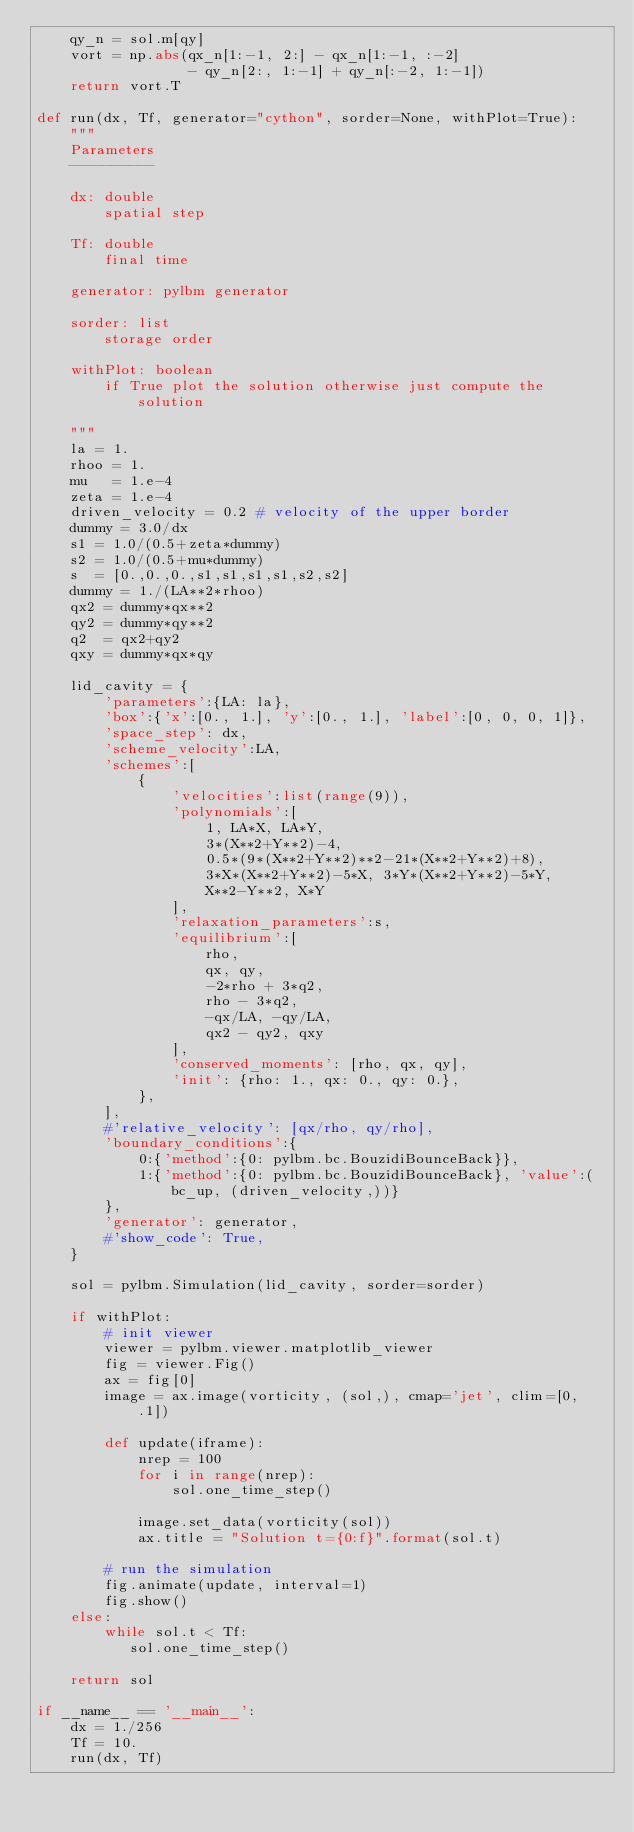<code> <loc_0><loc_0><loc_500><loc_500><_Python_>    qy_n = sol.m[qy]
    vort = np.abs(qx_n[1:-1, 2:] - qx_n[1:-1, :-2]
                  - qy_n[2:, 1:-1] + qy_n[:-2, 1:-1])
    return vort.T

def run(dx, Tf, generator="cython", sorder=None, withPlot=True):
    """
    Parameters
    ----------

    dx: double
        spatial step

    Tf: double
        final time

    generator: pylbm generator

    sorder: list
        storage order

    withPlot: boolean
        if True plot the solution otherwise just compute the solution

    """
    la = 1.
    rhoo = 1.
    mu   = 1.e-4
    zeta = 1.e-4
    driven_velocity = 0.2 # velocity of the upper border
    dummy = 3.0/dx
    s1 = 1.0/(0.5+zeta*dummy)
    s2 = 1.0/(0.5+mu*dummy)
    s  = [0.,0.,0.,s1,s1,s1,s1,s2,s2]
    dummy = 1./(LA**2*rhoo)
    qx2 = dummy*qx**2
    qy2 = dummy*qy**2
    q2  = qx2+qy2
    qxy = dummy*qx*qy

    lid_cavity = {
        'parameters':{LA: la},
        'box':{'x':[0., 1.], 'y':[0., 1.], 'label':[0, 0, 0, 1]},
        'space_step': dx,
        'scheme_velocity':LA,
        'schemes':[
            {
                'velocities':list(range(9)),
                'polynomials':[
                    1, LA*X, LA*Y,
                    3*(X**2+Y**2)-4,
                    0.5*(9*(X**2+Y**2)**2-21*(X**2+Y**2)+8),
                    3*X*(X**2+Y**2)-5*X, 3*Y*(X**2+Y**2)-5*Y,
                    X**2-Y**2, X*Y
                ],
                'relaxation_parameters':s,
                'equilibrium':[
                    rho,
                    qx, qy,
                    -2*rho + 3*q2,
                    rho - 3*q2,
                    -qx/LA, -qy/LA,
                    qx2 - qy2, qxy
                ],
                'conserved_moments': [rho, qx, qy],
                'init': {rho: 1., qx: 0., qy: 0.},
            },
        ],
        #'relative_velocity': [qx/rho, qy/rho],
        'boundary_conditions':{
            0:{'method':{0: pylbm.bc.BouzidiBounceBack}},
            1:{'method':{0: pylbm.bc.BouzidiBounceBack}, 'value':(bc_up, (driven_velocity,))}
        },
        'generator': generator,
        #'show_code': True,
    }

    sol = pylbm.Simulation(lid_cavity, sorder=sorder)

    if withPlot:
        # init viewer
        viewer = pylbm.viewer.matplotlib_viewer
        fig = viewer.Fig()
        ax = fig[0]
        image = ax.image(vorticity, (sol,), cmap='jet', clim=[0, .1])

        def update(iframe):
            nrep = 100
            for i in range(nrep):
                sol.one_time_step()

            image.set_data(vorticity(sol))
            ax.title = "Solution t={0:f}".format(sol.t)

        # run the simulation
        fig.animate(update, interval=1)
        fig.show()
    else:
        while sol.t < Tf:
           sol.one_time_step()

    return sol

if __name__ == '__main__':
    dx = 1./256
    Tf = 10.
    run(dx, Tf)
</code> 